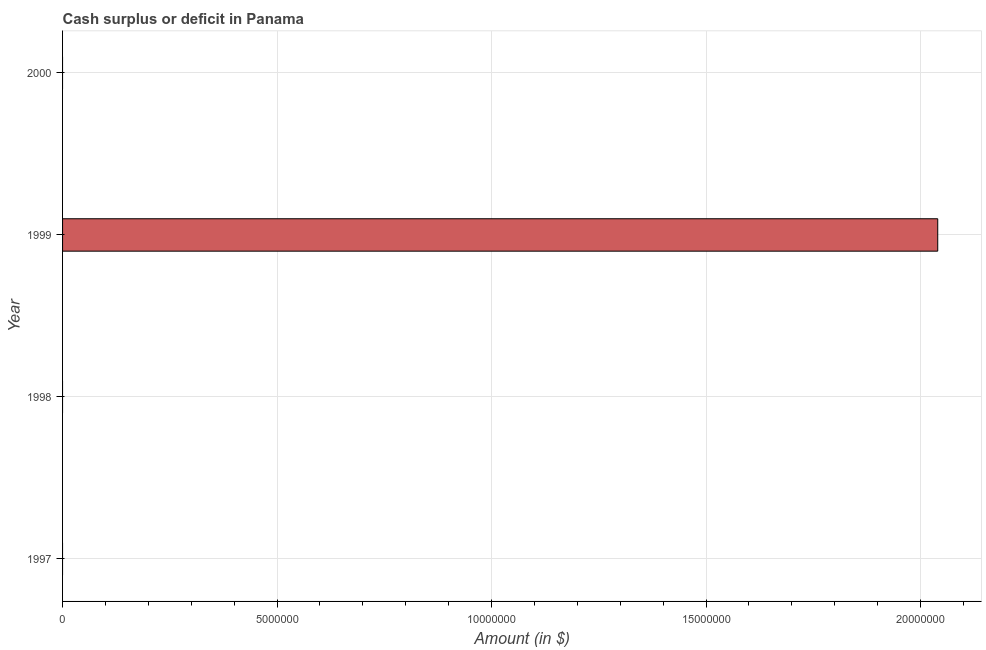Does the graph contain any zero values?
Give a very brief answer. Yes. Does the graph contain grids?
Provide a short and direct response. Yes. What is the title of the graph?
Your response must be concise. Cash surplus or deficit in Panama. What is the label or title of the X-axis?
Offer a very short reply. Amount (in $). What is the label or title of the Y-axis?
Give a very brief answer. Year. What is the cash surplus or deficit in 1998?
Provide a succinct answer. 0. Across all years, what is the maximum cash surplus or deficit?
Provide a succinct answer. 2.04e+07. In which year was the cash surplus or deficit maximum?
Keep it short and to the point. 1999. What is the sum of the cash surplus or deficit?
Ensure brevity in your answer.  2.04e+07. What is the average cash surplus or deficit per year?
Provide a short and direct response. 5.10e+06. What is the difference between the highest and the lowest cash surplus or deficit?
Provide a short and direct response. 2.04e+07. In how many years, is the cash surplus or deficit greater than the average cash surplus or deficit taken over all years?
Your answer should be very brief. 1. How many bars are there?
Your answer should be compact. 1. What is the difference between two consecutive major ticks on the X-axis?
Your response must be concise. 5.00e+06. Are the values on the major ticks of X-axis written in scientific E-notation?
Offer a terse response. No. What is the Amount (in $) in 1999?
Ensure brevity in your answer.  2.04e+07. 